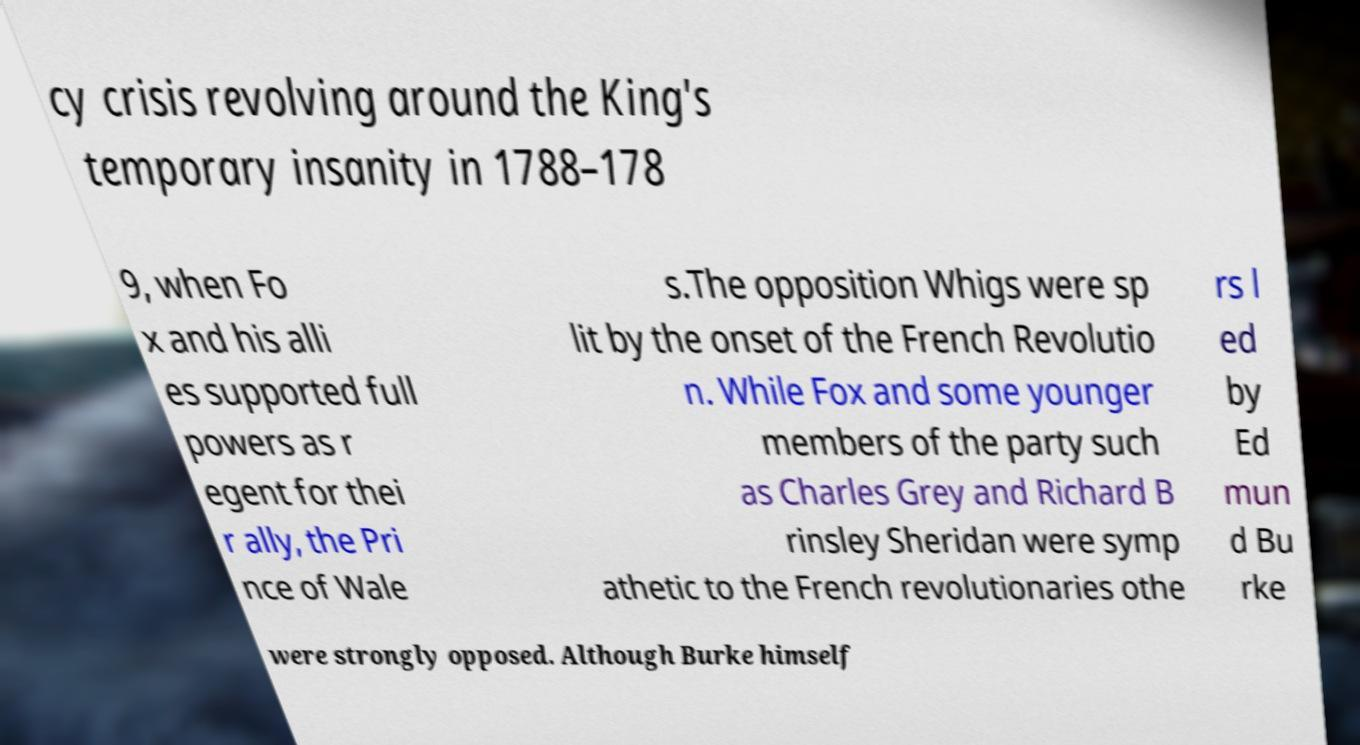What messages or text are displayed in this image? I need them in a readable, typed format. cy crisis revolving around the King's temporary insanity in 1788–178 9, when Fo x and his alli es supported full powers as r egent for thei r ally, the Pri nce of Wale s.The opposition Whigs were sp lit by the onset of the French Revolutio n. While Fox and some younger members of the party such as Charles Grey and Richard B rinsley Sheridan were symp athetic to the French revolutionaries othe rs l ed by Ed mun d Bu rke were strongly opposed. Although Burke himself 